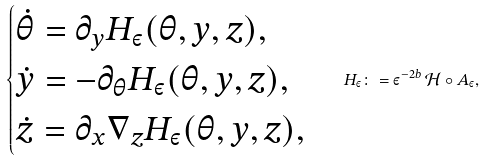<formula> <loc_0><loc_0><loc_500><loc_500>\begin{cases} \dot { \theta } = \partial _ { y } H _ { \varepsilon } ( \theta , y , z ) , \\ \dot { y } = - \partial _ { \theta } H _ { \varepsilon } ( \theta , y , z ) , \\ \dot { z } = \partial _ { x } \nabla _ { z } H _ { \varepsilon } ( \theta , y , z ) , \end{cases} H _ { \varepsilon } \colon = \varepsilon ^ { - 2 b } \, \mathcal { H } \circ A _ { \varepsilon } ,</formula> 